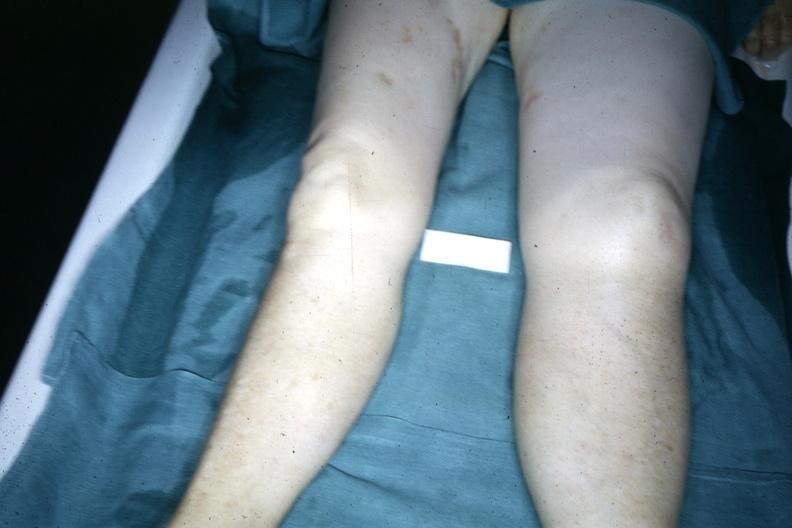what is present?
Answer the question using a single word or phrase. Edema 